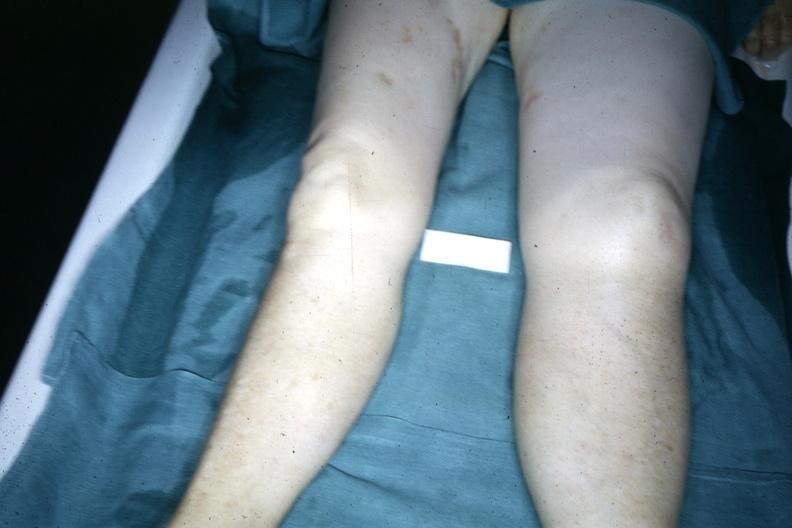what is present?
Answer the question using a single word or phrase. Edema 